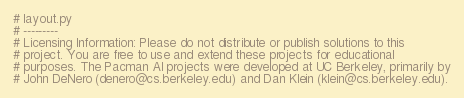Convert code to text. <code><loc_0><loc_0><loc_500><loc_500><_Python_># layout.py
# ---------
# Licensing Information: Please do not distribute or publish solutions to this
# project. You are free to use and extend these projects for educational
# purposes. The Pacman AI projects were developed at UC Berkeley, primarily by
# John DeNero (denero@cs.berkeley.edu) and Dan Klein (klein@cs.berkeley.edu).</code> 